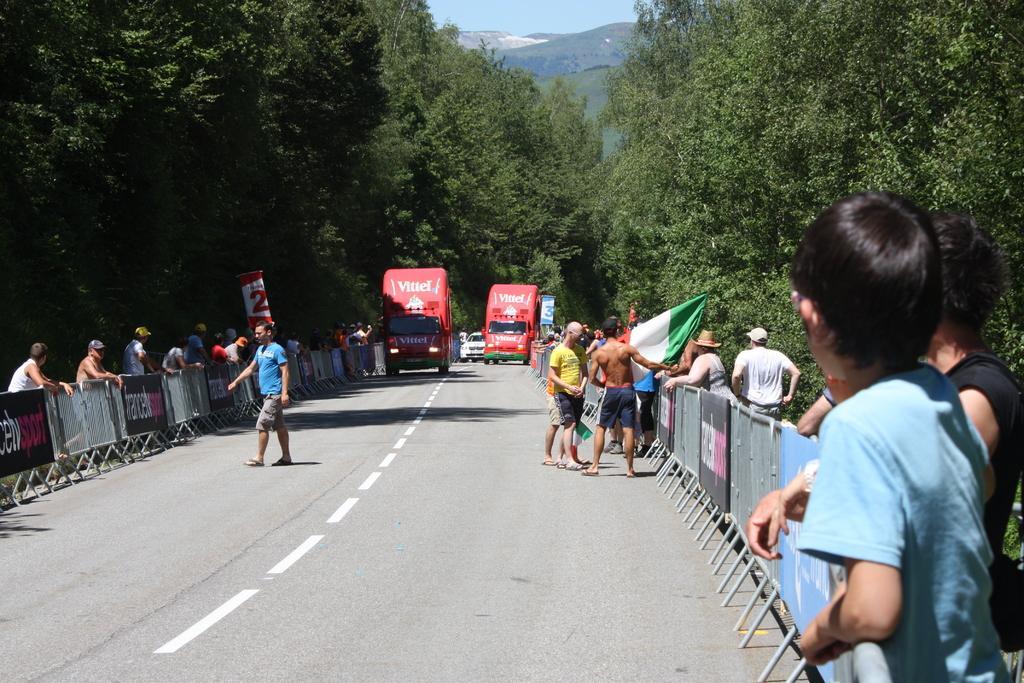Can you describe this image briefly? In this picture there are people and boundaries on the right and left side of the image, there are two vans and a car in the center of the image, there are trees in the background area of the image, there are posters on the boundaries and there is a flag in the image. 